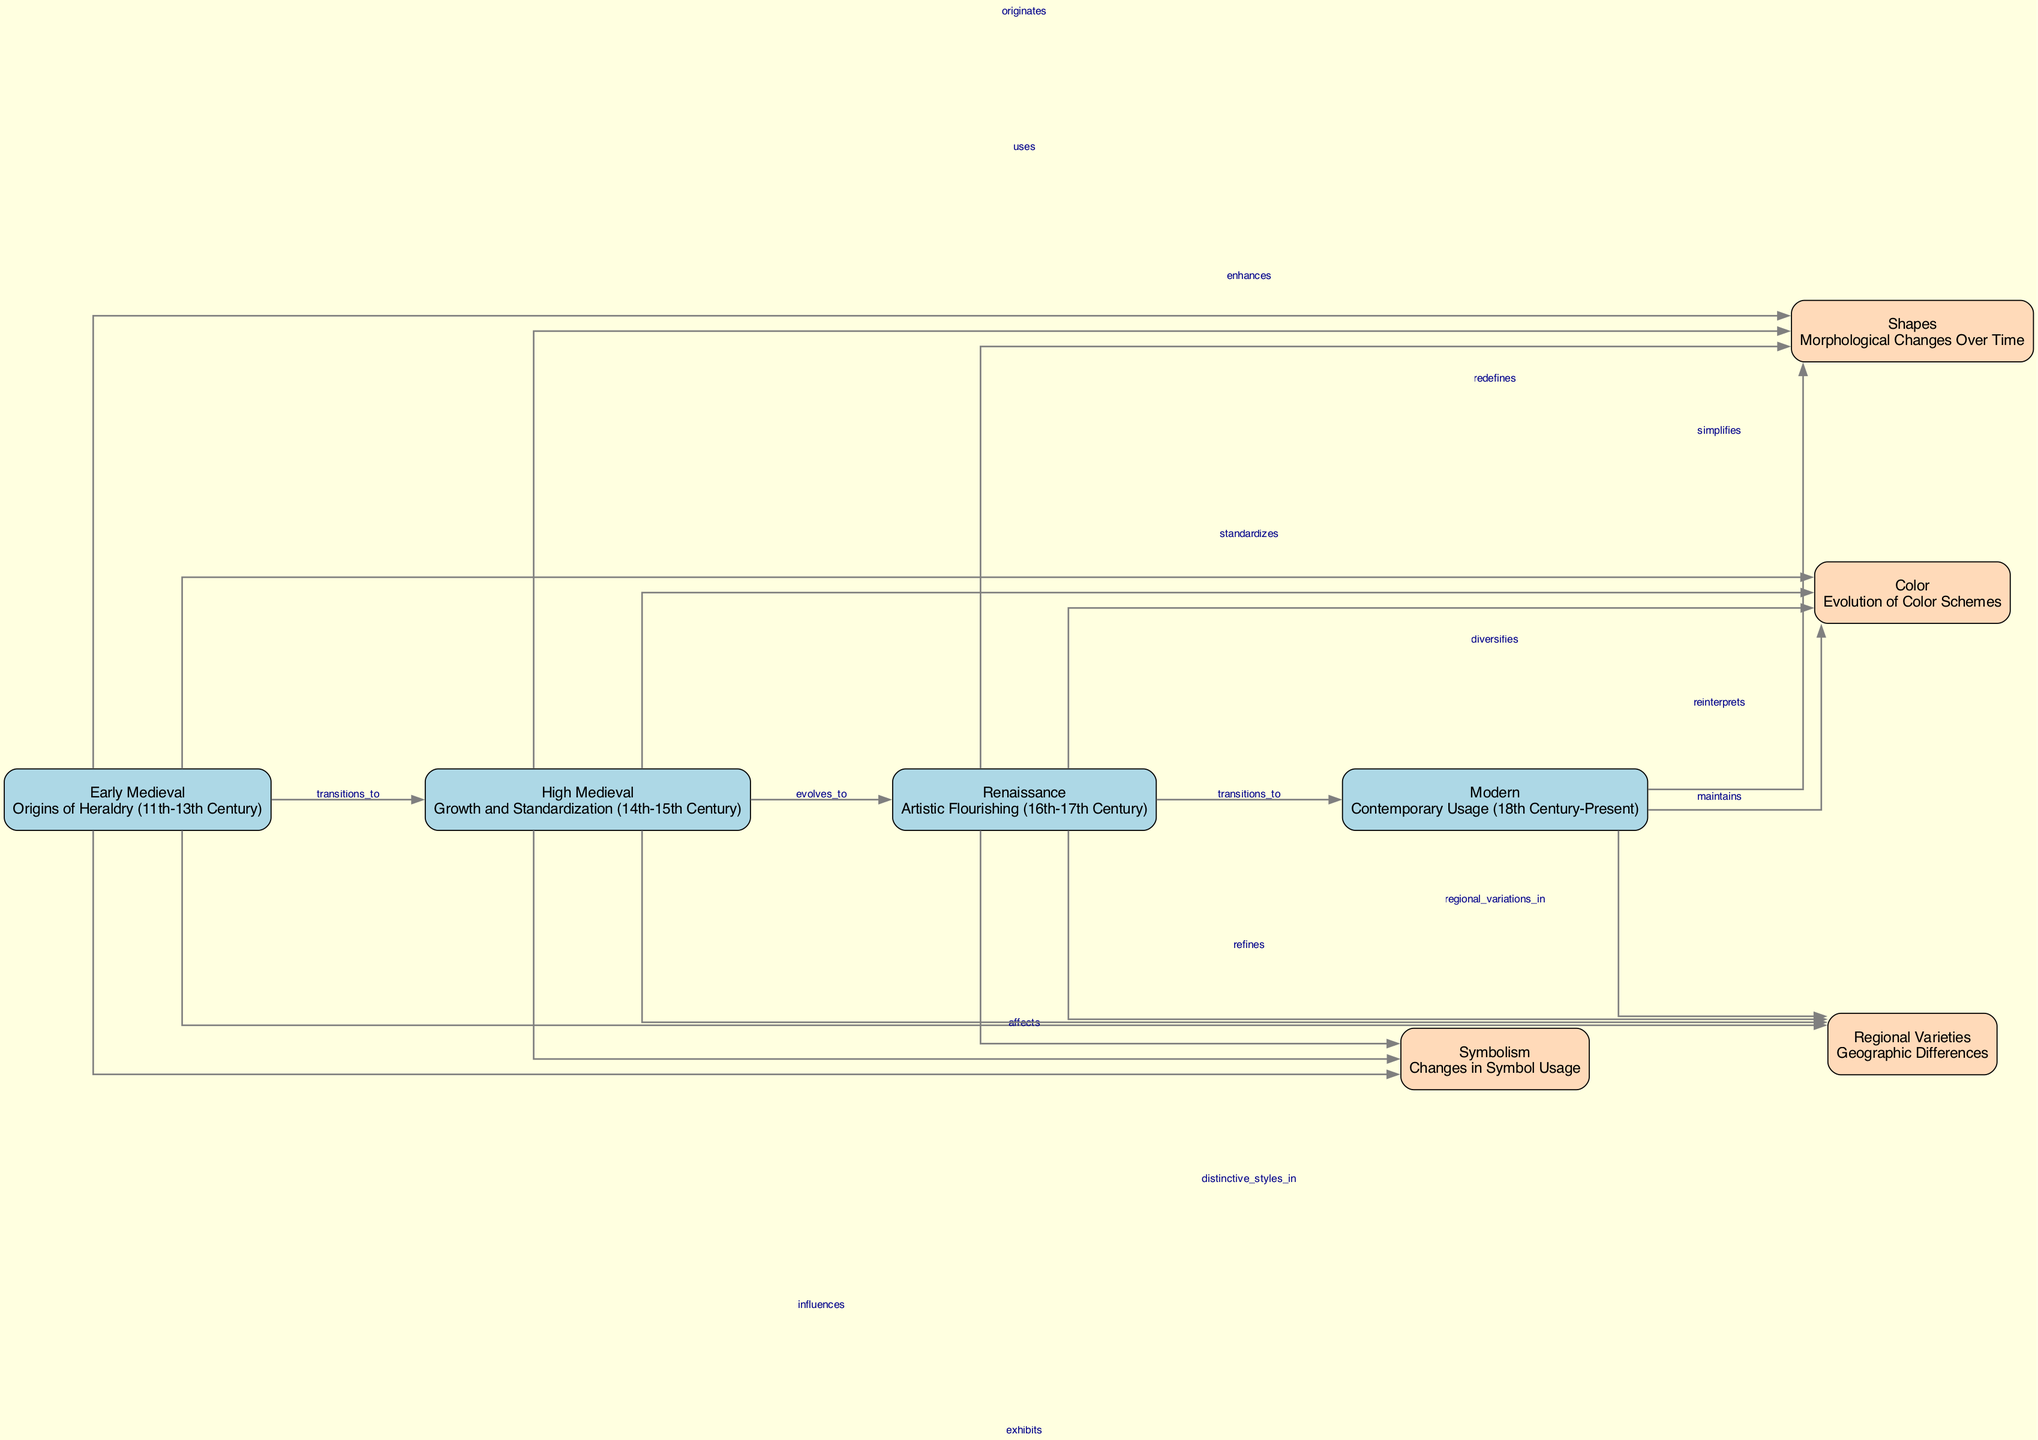What are the four main periods of heraldry evolution shown in the diagram? The diagram lists four main periods of heraldry: Early Medieval, High Medieval, Renaissance, and Modern. These are clearly labeled nodes in the diagram.
Answer: Early Medieval, High Medieval, Renaissance, Modern How many nodes are present in the diagram? The diagram contains a total of eight nodes, which include four main periods and four stylistic features.
Answer: 8 What relationship exists between the 'Early Medieval' and 'High Medieval' nodes? The diagram indicates a relationship labeled "transitions_to" from 'Early Medieval' to 'High Medieval', showing the evolution from one period to the next.
Answer: transitions_to Which stylistic feature is first influenced by 'Early Medieval'? The edge labeled "influences" connects 'Early Medieval' to 'Symbolism', indicating that this stylistic feature is first affected in that period.
Answer: Symbolism What unique characteristic does the 'Renaissance' node possess compared to earlier periods? The 'Renaissance' node uses the edge labeled "refines" to 'Symbolism', showing that it builds upon previous influences to enhance the complexity of symbolic use in heraldry.
Answer: refines How do color schemes evolve from 'High Medieval' to 'Modern'? Moving from 'High Medieval' to 'Modern', the diagram uses the edge labeled "reinterprets" to show how color schemes evolve over time, indicating a shift from traditional to contemporary interpretations.
Answer: reinterprets Which node exhibits geographic differences in style? The node labeled 'Regional Varieties' directly relates to the geographic aspect of heraldry, highlighting differences in coat of arms designs across different regions.
Answer: Regional Varieties In which period did the emphasis on shapes in coat of arms designs enhance? The edge shows that 'High Medieval' enhances 'Shapes', suggesting that this period focused on a more defined morphological aspect in designs.
Answer: High Medieval What is indicated about the relationship between 'Modern' and 'Regional Varieties'? The diagram shows that the 'Modern' node "maintains" 'Regional Varieties', suggesting that contemporary heraldry continues to recognize and uphold diverse regional styles.
Answer: maintains 